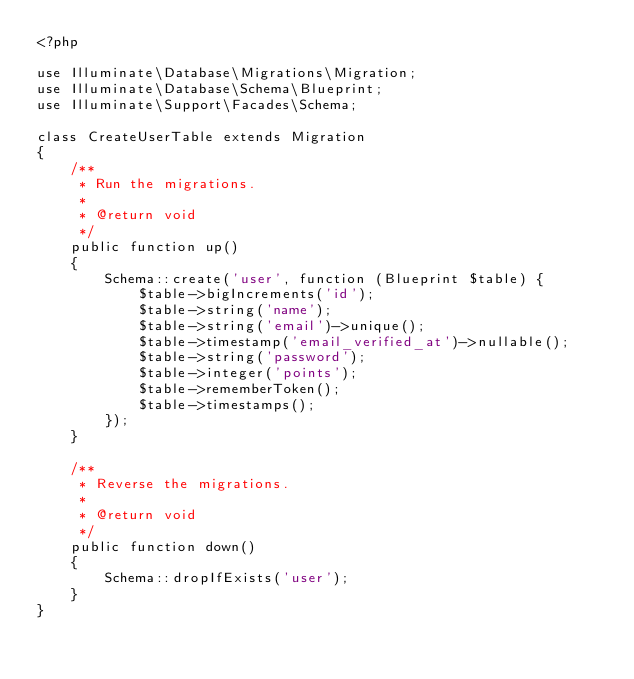<code> <loc_0><loc_0><loc_500><loc_500><_PHP_><?php

use Illuminate\Database\Migrations\Migration;
use Illuminate\Database\Schema\Blueprint;
use Illuminate\Support\Facades\Schema;

class CreateUserTable extends Migration
{
    /**
     * Run the migrations.
     *
     * @return void
     */
    public function up()
    {
        Schema::create('user', function (Blueprint $table) {
            $table->bigIncrements('id');
            $table->string('name');
            $table->string('email')->unique();
            $table->timestamp('email_verified_at')->nullable();
            $table->string('password');
            $table->integer('points');
            $table->rememberToken();
            $table->timestamps();
        });
    }

    /**
     * Reverse the migrations.
     *
     * @return void
     */
    public function down()
    {
        Schema::dropIfExists('user');
    }
}
</code> 